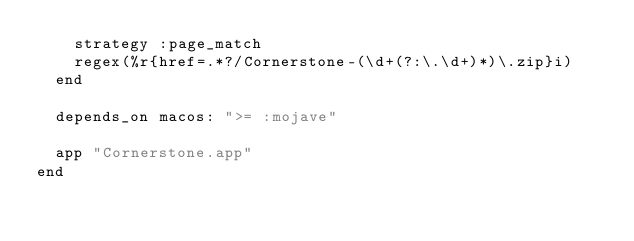Convert code to text. <code><loc_0><loc_0><loc_500><loc_500><_Ruby_>    strategy :page_match
    regex(%r{href=.*?/Cornerstone-(\d+(?:\.\d+)*)\.zip}i)
  end

  depends_on macos: ">= :mojave"

  app "Cornerstone.app"
end
</code> 